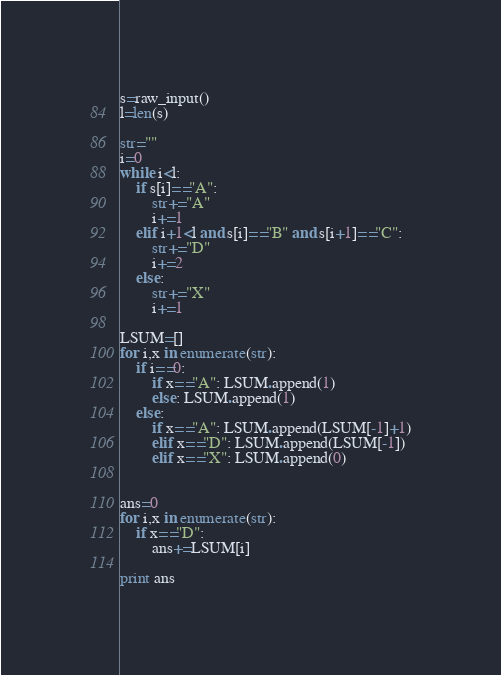<code> <loc_0><loc_0><loc_500><loc_500><_Python_>s=raw_input()
l=len(s)

str=""
i=0
while i<l:
	if s[i]=="A":
		str+="A"
		i+=1
	elif i+1<l and s[i]=="B" and s[i+1]=="C":
		str+="D"
		i+=2
	else:
		str+="X"
		i+=1

LSUM=[]
for i,x in enumerate(str):
	if i==0:
		if x=="A": LSUM.append(1)
		else: LSUM.append(1)
	else:
		if x=="A": LSUM.append(LSUM[-1]+1)
		elif x=="D": LSUM.append(LSUM[-1])
		elif x=="X": LSUM.append(0)


ans=0
for i,x in enumerate(str):
	if x=="D":
		ans+=LSUM[i]

print ans
</code> 